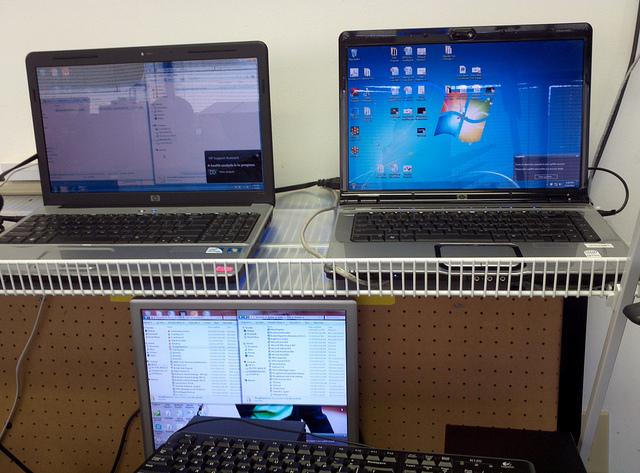What operating system do these computers run?
Write a very short answer. Windows. How many screens do you see?
Be succinct. 3. Who many people use these computer?
Give a very brief answer. 3. 